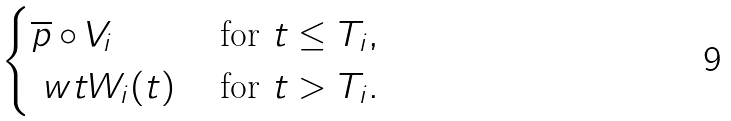Convert formula to latex. <formula><loc_0><loc_0><loc_500><loc_500>\begin{cases} \overline { p } \circ V _ { i } & \text { for } t \leq T _ { i } , \\ \ w t W _ { i } ( t ) & \text { for } t > T _ { i } . \\ \end{cases}</formula> 